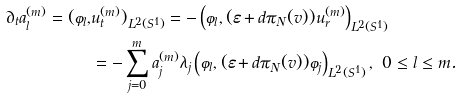Convert formula to latex. <formula><loc_0><loc_0><loc_500><loc_500>\partial _ { t } a ^ { ( m ) } _ { l } = ( \varphi _ { l } , & u ^ { ( m ) } _ { t } ) _ { L ^ { 2 } ( S ^ { 1 } ) } = - \left ( \varphi _ { l } , ( \varepsilon + d \pi _ { N } ( v ) ) u ^ { ( m ) } _ { r } \right ) _ { L ^ { 2 } ( S ^ { 1 } ) } \\ & = - \sum _ { j = 0 } ^ { m } a ^ { ( m ) } _ { j } \lambda _ { j } \left ( \varphi _ { l } , ( \varepsilon + d \pi _ { N } ( v ) ) \varphi _ { j } \right ) _ { L ^ { 2 } ( S ^ { 1 } ) } , \ 0 \leq l \leq m .</formula> 